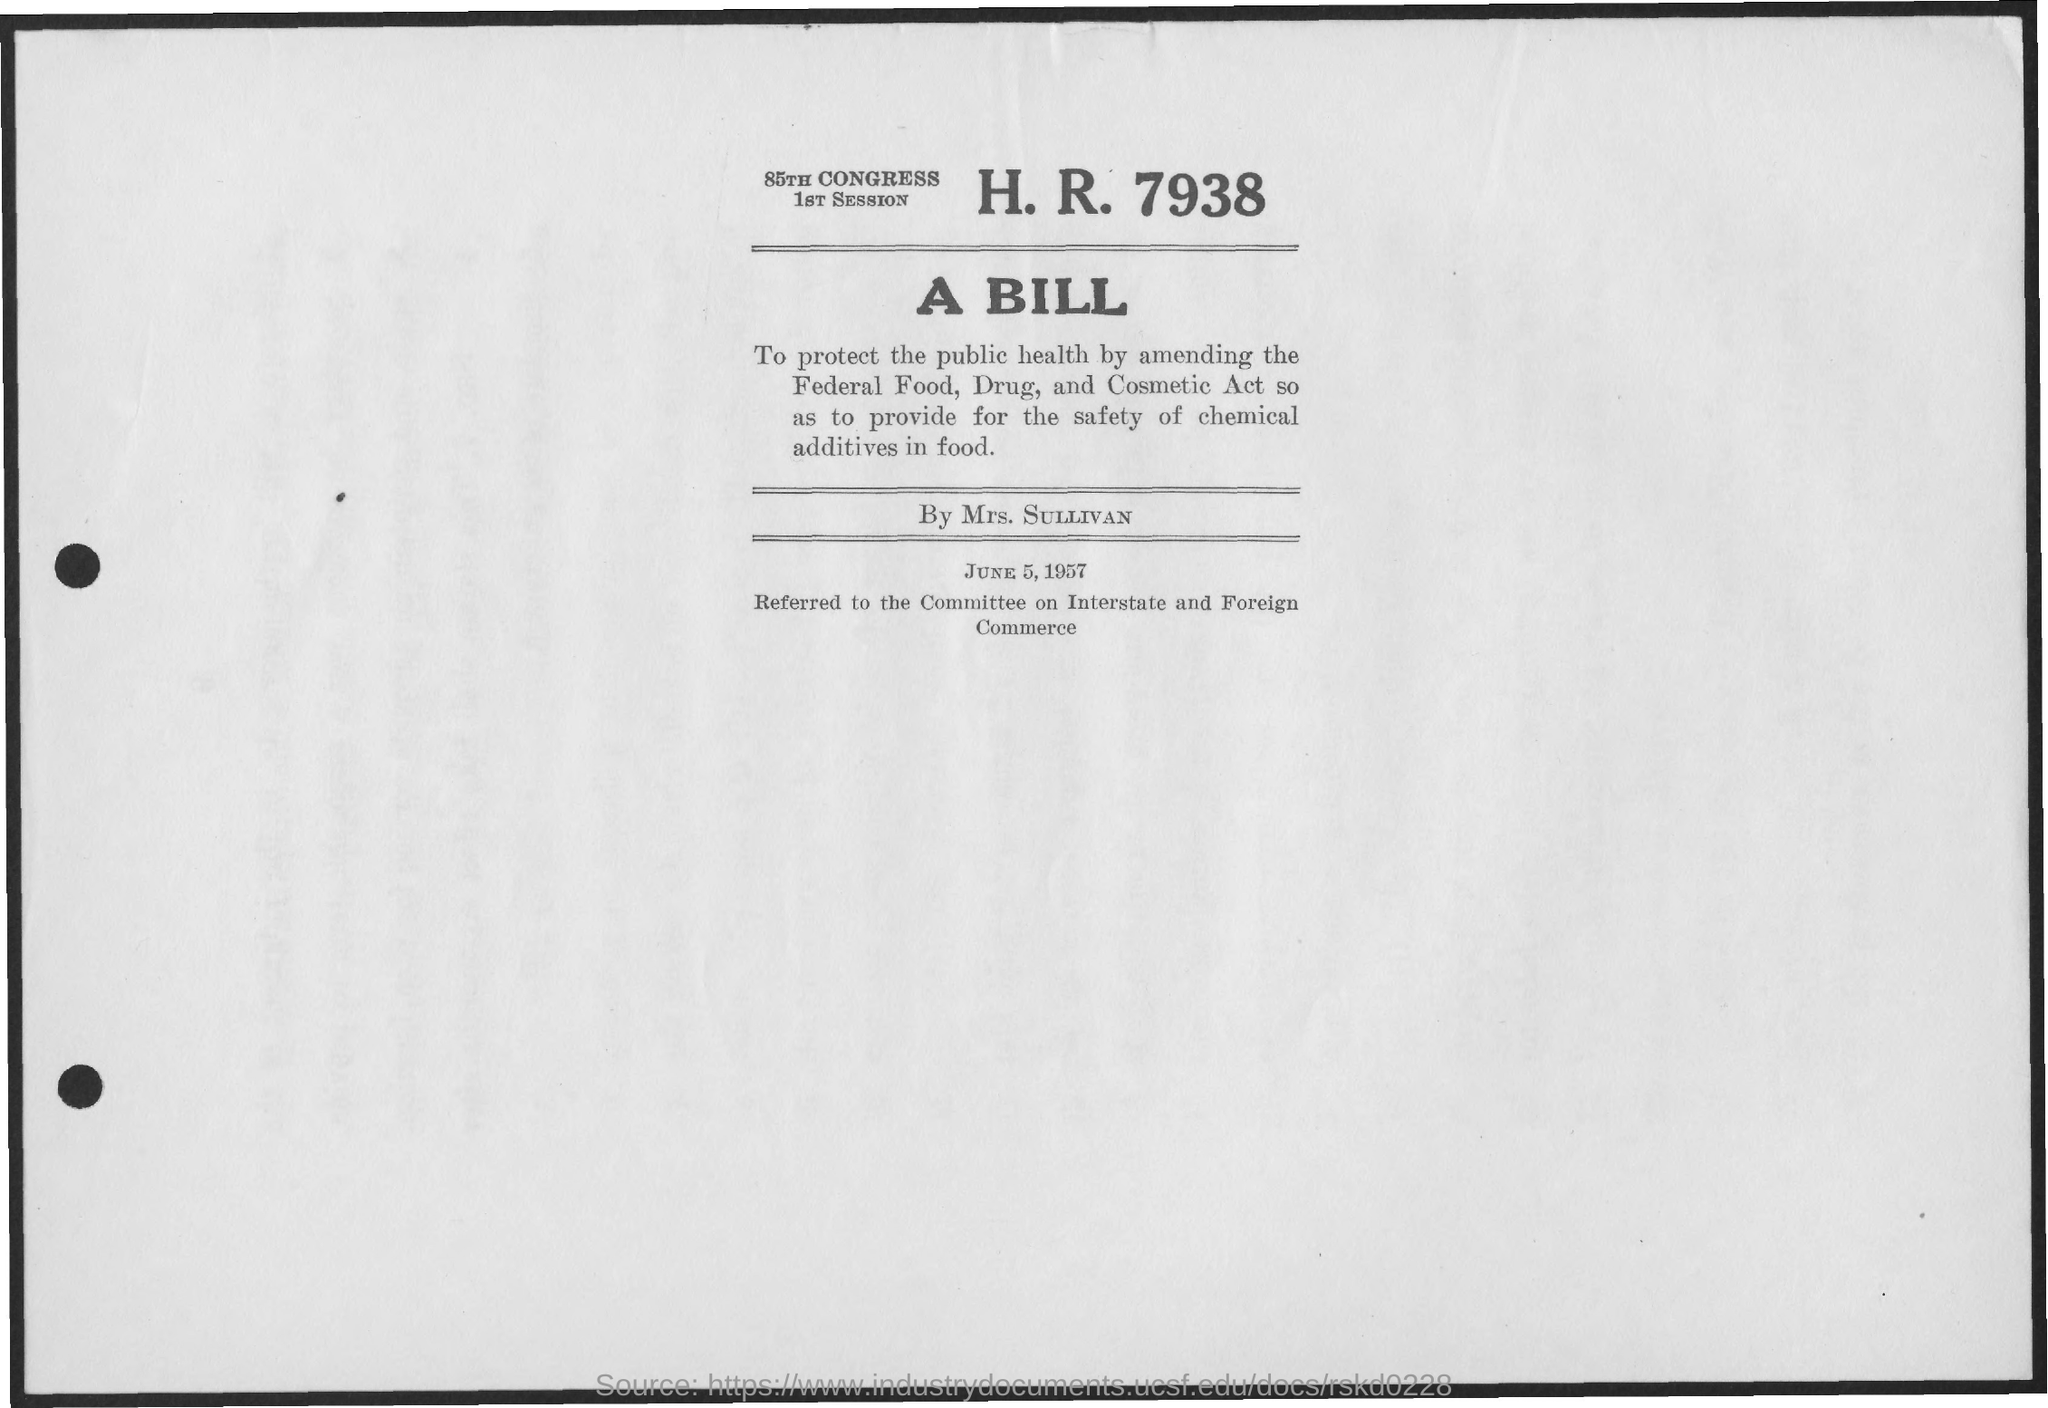What is the date on the document?
Your answer should be compact. June 5, 1957. 